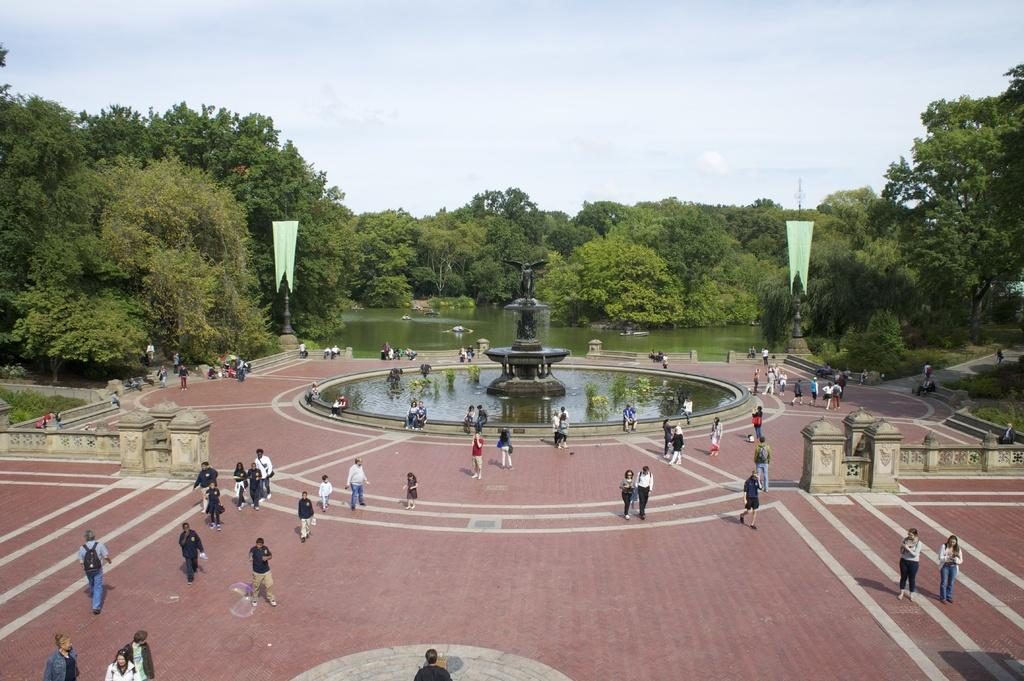How many people can be seen in the image? There are people in the image. What is the position of the people in the image? The people are on the ground. What type of structures are present in the image? There are walls in the image. What type of vegetation is visible in the image? Trees and plants are present in the image. What type of water feature can be seen in the image? Fountains are in the image. What type of vertical structures are present in the image? Poles are present in the image. What type of decorative items are visible in the image? Flags are visible in the image. What type of architectural feature is present in the image? Stairs are in the image. What part of the natural environment is visible in the image? The sky is visible in the image. What type of pleasure can be seen in the image? There is no indication of pleasure in the image; it simply depicts people, structures, and vegetation. How many girls are visible in the image? The provided facts do not mention the presence of any girls in the image. 